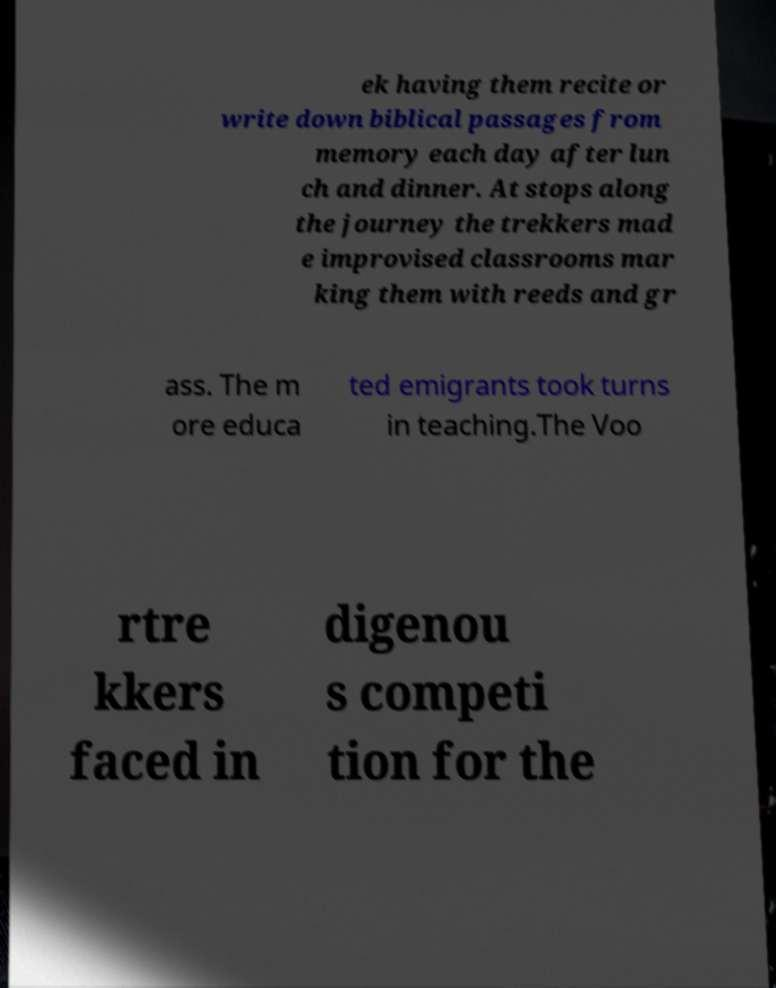I need the written content from this picture converted into text. Can you do that? ek having them recite or write down biblical passages from memory each day after lun ch and dinner. At stops along the journey the trekkers mad e improvised classrooms mar king them with reeds and gr ass. The m ore educa ted emigrants took turns in teaching.The Voo rtre kkers faced in digenou s competi tion for the 